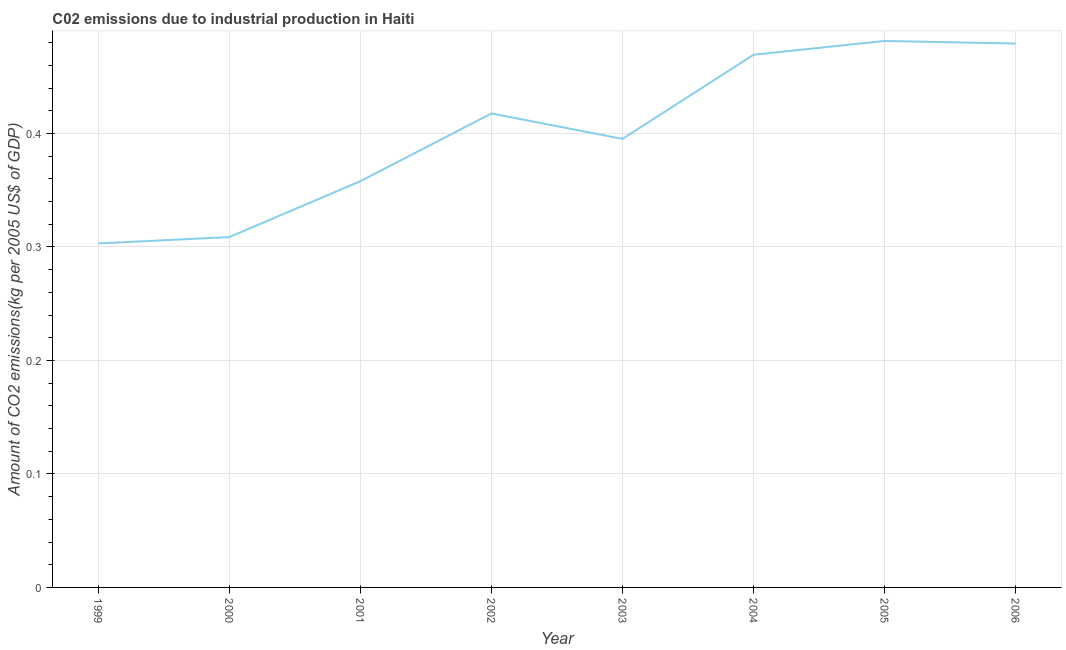What is the amount of co2 emissions in 2004?
Make the answer very short. 0.47. Across all years, what is the maximum amount of co2 emissions?
Offer a terse response. 0.48. Across all years, what is the minimum amount of co2 emissions?
Give a very brief answer. 0.3. In which year was the amount of co2 emissions maximum?
Keep it short and to the point. 2005. What is the sum of the amount of co2 emissions?
Offer a terse response. 3.21. What is the difference between the amount of co2 emissions in 2002 and 2004?
Keep it short and to the point. -0.05. What is the average amount of co2 emissions per year?
Your answer should be compact. 0.4. What is the median amount of co2 emissions?
Provide a succinct answer. 0.41. What is the ratio of the amount of co2 emissions in 2003 to that in 2006?
Your answer should be very brief. 0.82. Is the amount of co2 emissions in 2000 less than that in 2006?
Provide a short and direct response. Yes. What is the difference between the highest and the second highest amount of co2 emissions?
Offer a terse response. 0. What is the difference between the highest and the lowest amount of co2 emissions?
Make the answer very short. 0.18. In how many years, is the amount of co2 emissions greater than the average amount of co2 emissions taken over all years?
Your answer should be compact. 4. How many lines are there?
Provide a succinct answer. 1. Does the graph contain any zero values?
Keep it short and to the point. No. What is the title of the graph?
Offer a terse response. C02 emissions due to industrial production in Haiti. What is the label or title of the Y-axis?
Ensure brevity in your answer.  Amount of CO2 emissions(kg per 2005 US$ of GDP). What is the Amount of CO2 emissions(kg per 2005 US$ of GDP) of 1999?
Your response must be concise. 0.3. What is the Amount of CO2 emissions(kg per 2005 US$ of GDP) in 2000?
Ensure brevity in your answer.  0.31. What is the Amount of CO2 emissions(kg per 2005 US$ of GDP) in 2001?
Give a very brief answer. 0.36. What is the Amount of CO2 emissions(kg per 2005 US$ of GDP) of 2002?
Make the answer very short. 0.42. What is the Amount of CO2 emissions(kg per 2005 US$ of GDP) in 2003?
Ensure brevity in your answer.  0.4. What is the Amount of CO2 emissions(kg per 2005 US$ of GDP) of 2004?
Offer a terse response. 0.47. What is the Amount of CO2 emissions(kg per 2005 US$ of GDP) of 2005?
Offer a terse response. 0.48. What is the Amount of CO2 emissions(kg per 2005 US$ of GDP) in 2006?
Your response must be concise. 0.48. What is the difference between the Amount of CO2 emissions(kg per 2005 US$ of GDP) in 1999 and 2000?
Provide a succinct answer. -0.01. What is the difference between the Amount of CO2 emissions(kg per 2005 US$ of GDP) in 1999 and 2001?
Your answer should be very brief. -0.05. What is the difference between the Amount of CO2 emissions(kg per 2005 US$ of GDP) in 1999 and 2002?
Provide a short and direct response. -0.11. What is the difference between the Amount of CO2 emissions(kg per 2005 US$ of GDP) in 1999 and 2003?
Your answer should be very brief. -0.09. What is the difference between the Amount of CO2 emissions(kg per 2005 US$ of GDP) in 1999 and 2004?
Offer a very short reply. -0.17. What is the difference between the Amount of CO2 emissions(kg per 2005 US$ of GDP) in 1999 and 2005?
Ensure brevity in your answer.  -0.18. What is the difference between the Amount of CO2 emissions(kg per 2005 US$ of GDP) in 1999 and 2006?
Your answer should be very brief. -0.18. What is the difference between the Amount of CO2 emissions(kg per 2005 US$ of GDP) in 2000 and 2001?
Give a very brief answer. -0.05. What is the difference between the Amount of CO2 emissions(kg per 2005 US$ of GDP) in 2000 and 2002?
Give a very brief answer. -0.11. What is the difference between the Amount of CO2 emissions(kg per 2005 US$ of GDP) in 2000 and 2003?
Provide a succinct answer. -0.09. What is the difference between the Amount of CO2 emissions(kg per 2005 US$ of GDP) in 2000 and 2004?
Keep it short and to the point. -0.16. What is the difference between the Amount of CO2 emissions(kg per 2005 US$ of GDP) in 2000 and 2005?
Your answer should be compact. -0.17. What is the difference between the Amount of CO2 emissions(kg per 2005 US$ of GDP) in 2000 and 2006?
Keep it short and to the point. -0.17. What is the difference between the Amount of CO2 emissions(kg per 2005 US$ of GDP) in 2001 and 2002?
Ensure brevity in your answer.  -0.06. What is the difference between the Amount of CO2 emissions(kg per 2005 US$ of GDP) in 2001 and 2003?
Keep it short and to the point. -0.04. What is the difference between the Amount of CO2 emissions(kg per 2005 US$ of GDP) in 2001 and 2004?
Your response must be concise. -0.11. What is the difference between the Amount of CO2 emissions(kg per 2005 US$ of GDP) in 2001 and 2005?
Your response must be concise. -0.12. What is the difference between the Amount of CO2 emissions(kg per 2005 US$ of GDP) in 2001 and 2006?
Keep it short and to the point. -0.12. What is the difference between the Amount of CO2 emissions(kg per 2005 US$ of GDP) in 2002 and 2003?
Keep it short and to the point. 0.02. What is the difference between the Amount of CO2 emissions(kg per 2005 US$ of GDP) in 2002 and 2004?
Your answer should be compact. -0.05. What is the difference between the Amount of CO2 emissions(kg per 2005 US$ of GDP) in 2002 and 2005?
Offer a very short reply. -0.06. What is the difference between the Amount of CO2 emissions(kg per 2005 US$ of GDP) in 2002 and 2006?
Offer a very short reply. -0.06. What is the difference between the Amount of CO2 emissions(kg per 2005 US$ of GDP) in 2003 and 2004?
Make the answer very short. -0.07. What is the difference between the Amount of CO2 emissions(kg per 2005 US$ of GDP) in 2003 and 2005?
Offer a very short reply. -0.09. What is the difference between the Amount of CO2 emissions(kg per 2005 US$ of GDP) in 2003 and 2006?
Keep it short and to the point. -0.08. What is the difference between the Amount of CO2 emissions(kg per 2005 US$ of GDP) in 2004 and 2005?
Provide a short and direct response. -0.01. What is the difference between the Amount of CO2 emissions(kg per 2005 US$ of GDP) in 2004 and 2006?
Make the answer very short. -0.01. What is the difference between the Amount of CO2 emissions(kg per 2005 US$ of GDP) in 2005 and 2006?
Your answer should be very brief. 0. What is the ratio of the Amount of CO2 emissions(kg per 2005 US$ of GDP) in 1999 to that in 2000?
Give a very brief answer. 0.98. What is the ratio of the Amount of CO2 emissions(kg per 2005 US$ of GDP) in 1999 to that in 2001?
Provide a short and direct response. 0.85. What is the ratio of the Amount of CO2 emissions(kg per 2005 US$ of GDP) in 1999 to that in 2002?
Offer a very short reply. 0.73. What is the ratio of the Amount of CO2 emissions(kg per 2005 US$ of GDP) in 1999 to that in 2003?
Make the answer very short. 0.77. What is the ratio of the Amount of CO2 emissions(kg per 2005 US$ of GDP) in 1999 to that in 2004?
Offer a very short reply. 0.65. What is the ratio of the Amount of CO2 emissions(kg per 2005 US$ of GDP) in 1999 to that in 2005?
Give a very brief answer. 0.63. What is the ratio of the Amount of CO2 emissions(kg per 2005 US$ of GDP) in 1999 to that in 2006?
Ensure brevity in your answer.  0.63. What is the ratio of the Amount of CO2 emissions(kg per 2005 US$ of GDP) in 2000 to that in 2001?
Ensure brevity in your answer.  0.86. What is the ratio of the Amount of CO2 emissions(kg per 2005 US$ of GDP) in 2000 to that in 2002?
Offer a very short reply. 0.74. What is the ratio of the Amount of CO2 emissions(kg per 2005 US$ of GDP) in 2000 to that in 2003?
Provide a short and direct response. 0.78. What is the ratio of the Amount of CO2 emissions(kg per 2005 US$ of GDP) in 2000 to that in 2004?
Give a very brief answer. 0.66. What is the ratio of the Amount of CO2 emissions(kg per 2005 US$ of GDP) in 2000 to that in 2005?
Provide a short and direct response. 0.64. What is the ratio of the Amount of CO2 emissions(kg per 2005 US$ of GDP) in 2000 to that in 2006?
Provide a short and direct response. 0.64. What is the ratio of the Amount of CO2 emissions(kg per 2005 US$ of GDP) in 2001 to that in 2002?
Offer a very short reply. 0.86. What is the ratio of the Amount of CO2 emissions(kg per 2005 US$ of GDP) in 2001 to that in 2003?
Provide a short and direct response. 0.91. What is the ratio of the Amount of CO2 emissions(kg per 2005 US$ of GDP) in 2001 to that in 2004?
Make the answer very short. 0.76. What is the ratio of the Amount of CO2 emissions(kg per 2005 US$ of GDP) in 2001 to that in 2005?
Give a very brief answer. 0.74. What is the ratio of the Amount of CO2 emissions(kg per 2005 US$ of GDP) in 2001 to that in 2006?
Offer a terse response. 0.75. What is the ratio of the Amount of CO2 emissions(kg per 2005 US$ of GDP) in 2002 to that in 2003?
Your response must be concise. 1.06. What is the ratio of the Amount of CO2 emissions(kg per 2005 US$ of GDP) in 2002 to that in 2004?
Provide a succinct answer. 0.89. What is the ratio of the Amount of CO2 emissions(kg per 2005 US$ of GDP) in 2002 to that in 2005?
Your answer should be very brief. 0.87. What is the ratio of the Amount of CO2 emissions(kg per 2005 US$ of GDP) in 2002 to that in 2006?
Provide a succinct answer. 0.87. What is the ratio of the Amount of CO2 emissions(kg per 2005 US$ of GDP) in 2003 to that in 2004?
Your response must be concise. 0.84. What is the ratio of the Amount of CO2 emissions(kg per 2005 US$ of GDP) in 2003 to that in 2005?
Offer a very short reply. 0.82. What is the ratio of the Amount of CO2 emissions(kg per 2005 US$ of GDP) in 2003 to that in 2006?
Ensure brevity in your answer.  0.82. What is the ratio of the Amount of CO2 emissions(kg per 2005 US$ of GDP) in 2004 to that in 2005?
Your answer should be compact. 0.97. What is the ratio of the Amount of CO2 emissions(kg per 2005 US$ of GDP) in 2004 to that in 2006?
Give a very brief answer. 0.98. What is the ratio of the Amount of CO2 emissions(kg per 2005 US$ of GDP) in 2005 to that in 2006?
Give a very brief answer. 1. 